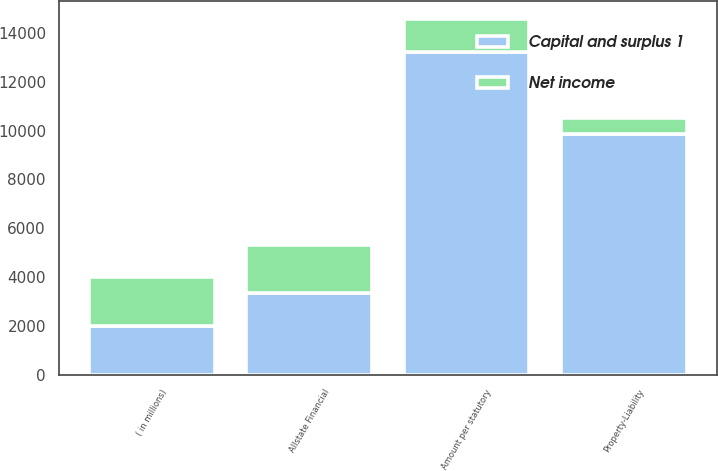Convert chart to OTSL. <chart><loc_0><loc_0><loc_500><loc_500><stacked_bar_chart><ecel><fcel>( in millions)<fcel>Property-Liability<fcel>Allstate Financial<fcel>Amount per statutory<nl><fcel>Net income<fcel>2008<fcel>624<fcel>1983<fcel>1359<nl><fcel>Capital and surplus 1<fcel>2008<fcel>9878<fcel>3335<fcel>13213<nl></chart> 